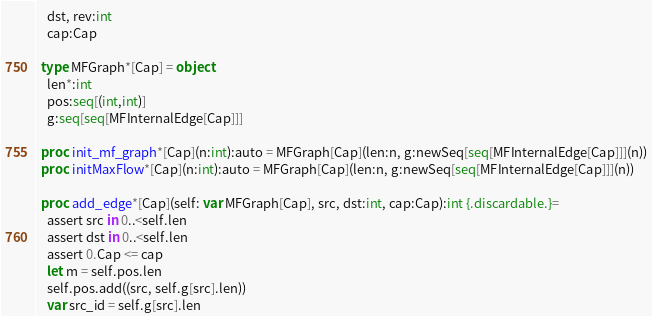Convert code to text. <code><loc_0><loc_0><loc_500><loc_500><_Nim_>    dst, rev:int
    cap:Cap
  
  type MFGraph*[Cap] = object
    len*:int
    pos:seq[(int,int)]
    g:seq[seq[MFInternalEdge[Cap]]]
  
  proc init_mf_graph*[Cap](n:int):auto = MFGraph[Cap](len:n, g:newSeq[seq[MFInternalEdge[Cap]]](n))
  proc initMaxFlow*[Cap](n:int):auto = MFGraph[Cap](len:n, g:newSeq[seq[MFInternalEdge[Cap]]](n))
  
  proc add_edge*[Cap](self: var MFGraph[Cap], src, dst:int, cap:Cap):int {.discardable.}=
    assert src in 0..<self.len
    assert dst in 0..<self.len
    assert 0.Cap <= cap
    let m = self.pos.len
    self.pos.add((src, self.g[src].len))
    var src_id = self.g[src].len</code> 